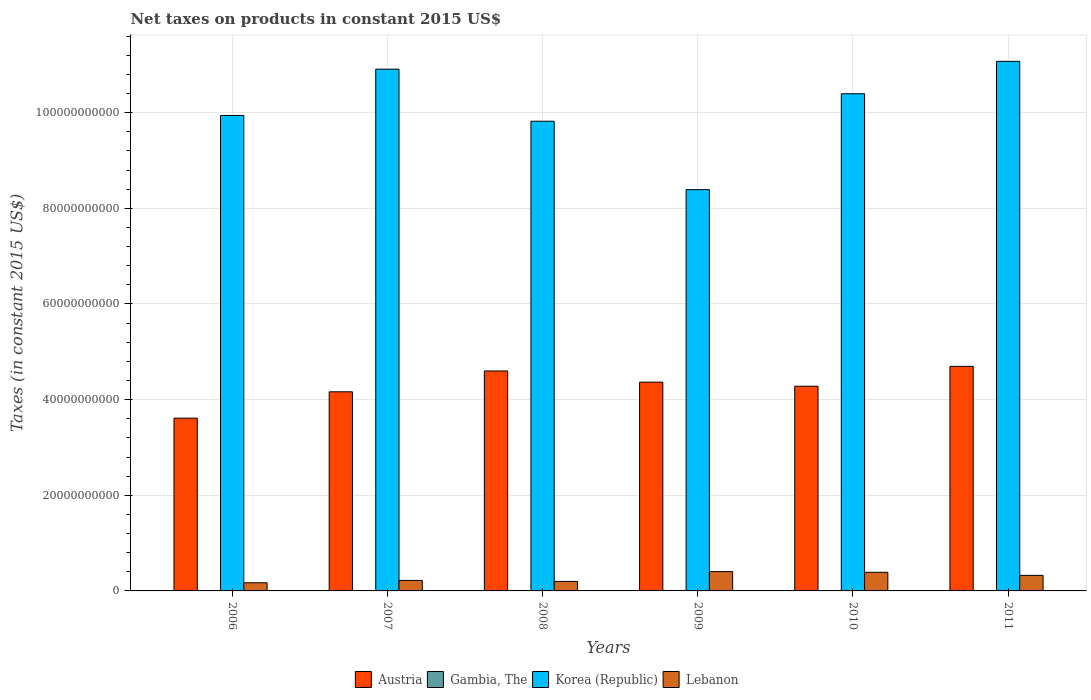How many different coloured bars are there?
Your answer should be compact. 4. How many groups of bars are there?
Give a very brief answer. 6. Are the number of bars on each tick of the X-axis equal?
Offer a very short reply. Yes. How many bars are there on the 5th tick from the right?
Give a very brief answer. 4. What is the label of the 3rd group of bars from the left?
Give a very brief answer. 2008. In how many cases, is the number of bars for a given year not equal to the number of legend labels?
Give a very brief answer. 0. What is the net taxes on products in Austria in 2008?
Provide a short and direct response. 4.60e+1. Across all years, what is the maximum net taxes on products in Austria?
Your answer should be compact. 4.70e+1. Across all years, what is the minimum net taxes on products in Korea (Republic)?
Provide a short and direct response. 8.39e+1. What is the total net taxes on products in Lebanon in the graph?
Provide a short and direct response. 1.71e+1. What is the difference between the net taxes on products in Austria in 2007 and that in 2010?
Your answer should be very brief. -1.16e+09. What is the difference between the net taxes on products in Gambia, The in 2008 and the net taxes on products in Lebanon in 2006?
Your response must be concise. -1.61e+09. What is the average net taxes on products in Gambia, The per year?
Keep it short and to the point. 8.42e+07. In the year 2010, what is the difference between the net taxes on products in Lebanon and net taxes on products in Korea (Republic)?
Provide a succinct answer. -1.00e+11. In how many years, is the net taxes on products in Lebanon greater than 104000000000 US$?
Give a very brief answer. 0. What is the ratio of the net taxes on products in Lebanon in 2007 to that in 2008?
Offer a terse response. 1.1. Is the difference between the net taxes on products in Lebanon in 2008 and 2009 greater than the difference between the net taxes on products in Korea (Republic) in 2008 and 2009?
Offer a terse response. No. What is the difference between the highest and the second highest net taxes on products in Lebanon?
Your response must be concise. 1.52e+08. What is the difference between the highest and the lowest net taxes on products in Austria?
Provide a short and direct response. 1.08e+1. In how many years, is the net taxes on products in Lebanon greater than the average net taxes on products in Lebanon taken over all years?
Ensure brevity in your answer.  3. Is it the case that in every year, the sum of the net taxes on products in Korea (Republic) and net taxes on products in Gambia, The is greater than the sum of net taxes on products in Lebanon and net taxes on products in Austria?
Make the answer very short. No. What does the 2nd bar from the right in 2011 represents?
Your response must be concise. Korea (Republic). How many bars are there?
Your answer should be very brief. 24. Are all the bars in the graph horizontal?
Keep it short and to the point. No. How many years are there in the graph?
Give a very brief answer. 6. What is the difference between two consecutive major ticks on the Y-axis?
Offer a terse response. 2.00e+1. Are the values on the major ticks of Y-axis written in scientific E-notation?
Ensure brevity in your answer.  No. How many legend labels are there?
Keep it short and to the point. 4. How are the legend labels stacked?
Give a very brief answer. Horizontal. What is the title of the graph?
Make the answer very short. Net taxes on products in constant 2015 US$. What is the label or title of the X-axis?
Provide a short and direct response. Years. What is the label or title of the Y-axis?
Offer a terse response. Taxes (in constant 2015 US$). What is the Taxes (in constant 2015 US$) of Austria in 2006?
Keep it short and to the point. 3.61e+1. What is the Taxes (in constant 2015 US$) in Gambia, The in 2006?
Provide a short and direct response. 6.61e+07. What is the Taxes (in constant 2015 US$) of Korea (Republic) in 2006?
Your answer should be very brief. 9.94e+1. What is the Taxes (in constant 2015 US$) of Lebanon in 2006?
Provide a short and direct response. 1.70e+09. What is the Taxes (in constant 2015 US$) in Austria in 2007?
Offer a terse response. 4.16e+1. What is the Taxes (in constant 2015 US$) of Gambia, The in 2007?
Provide a succinct answer. 8.66e+07. What is the Taxes (in constant 2015 US$) in Korea (Republic) in 2007?
Provide a succinct answer. 1.09e+11. What is the Taxes (in constant 2015 US$) of Lebanon in 2007?
Ensure brevity in your answer.  2.20e+09. What is the Taxes (in constant 2015 US$) of Austria in 2008?
Give a very brief answer. 4.60e+1. What is the Taxes (in constant 2015 US$) in Gambia, The in 2008?
Your response must be concise. 8.92e+07. What is the Taxes (in constant 2015 US$) in Korea (Republic) in 2008?
Provide a succinct answer. 9.82e+1. What is the Taxes (in constant 2015 US$) of Lebanon in 2008?
Your answer should be compact. 1.99e+09. What is the Taxes (in constant 2015 US$) of Austria in 2009?
Provide a succinct answer. 4.37e+1. What is the Taxes (in constant 2015 US$) in Gambia, The in 2009?
Give a very brief answer. 9.48e+07. What is the Taxes (in constant 2015 US$) in Korea (Republic) in 2009?
Keep it short and to the point. 8.39e+1. What is the Taxes (in constant 2015 US$) in Lebanon in 2009?
Your response must be concise. 4.04e+09. What is the Taxes (in constant 2015 US$) in Austria in 2010?
Give a very brief answer. 4.28e+1. What is the Taxes (in constant 2015 US$) in Gambia, The in 2010?
Offer a terse response. 8.39e+07. What is the Taxes (in constant 2015 US$) of Korea (Republic) in 2010?
Make the answer very short. 1.04e+11. What is the Taxes (in constant 2015 US$) of Lebanon in 2010?
Your answer should be compact. 3.89e+09. What is the Taxes (in constant 2015 US$) in Austria in 2011?
Your response must be concise. 4.70e+1. What is the Taxes (in constant 2015 US$) in Gambia, The in 2011?
Provide a succinct answer. 8.46e+07. What is the Taxes (in constant 2015 US$) in Korea (Republic) in 2011?
Provide a short and direct response. 1.11e+11. What is the Taxes (in constant 2015 US$) in Lebanon in 2011?
Offer a terse response. 3.25e+09. Across all years, what is the maximum Taxes (in constant 2015 US$) in Austria?
Offer a terse response. 4.70e+1. Across all years, what is the maximum Taxes (in constant 2015 US$) in Gambia, The?
Your answer should be very brief. 9.48e+07. Across all years, what is the maximum Taxes (in constant 2015 US$) in Korea (Republic)?
Provide a short and direct response. 1.11e+11. Across all years, what is the maximum Taxes (in constant 2015 US$) of Lebanon?
Keep it short and to the point. 4.04e+09. Across all years, what is the minimum Taxes (in constant 2015 US$) of Austria?
Make the answer very short. 3.61e+1. Across all years, what is the minimum Taxes (in constant 2015 US$) in Gambia, The?
Keep it short and to the point. 6.61e+07. Across all years, what is the minimum Taxes (in constant 2015 US$) of Korea (Republic)?
Your answer should be compact. 8.39e+1. Across all years, what is the minimum Taxes (in constant 2015 US$) in Lebanon?
Your answer should be very brief. 1.70e+09. What is the total Taxes (in constant 2015 US$) in Austria in the graph?
Make the answer very short. 2.57e+11. What is the total Taxes (in constant 2015 US$) in Gambia, The in the graph?
Make the answer very short. 5.05e+08. What is the total Taxes (in constant 2015 US$) of Korea (Republic) in the graph?
Your answer should be compact. 6.05e+11. What is the total Taxes (in constant 2015 US$) in Lebanon in the graph?
Ensure brevity in your answer.  1.71e+1. What is the difference between the Taxes (in constant 2015 US$) in Austria in 2006 and that in 2007?
Your answer should be very brief. -5.51e+09. What is the difference between the Taxes (in constant 2015 US$) of Gambia, The in 2006 and that in 2007?
Your answer should be very brief. -2.05e+07. What is the difference between the Taxes (in constant 2015 US$) of Korea (Republic) in 2006 and that in 2007?
Your answer should be very brief. -9.68e+09. What is the difference between the Taxes (in constant 2015 US$) of Lebanon in 2006 and that in 2007?
Your answer should be compact. -4.94e+08. What is the difference between the Taxes (in constant 2015 US$) of Austria in 2006 and that in 2008?
Your answer should be compact. -9.87e+09. What is the difference between the Taxes (in constant 2015 US$) in Gambia, The in 2006 and that in 2008?
Make the answer very short. -2.31e+07. What is the difference between the Taxes (in constant 2015 US$) in Korea (Republic) in 2006 and that in 2008?
Give a very brief answer. 1.21e+09. What is the difference between the Taxes (in constant 2015 US$) of Lebanon in 2006 and that in 2008?
Your answer should be very brief. -2.86e+08. What is the difference between the Taxes (in constant 2015 US$) of Austria in 2006 and that in 2009?
Provide a succinct answer. -7.53e+09. What is the difference between the Taxes (in constant 2015 US$) of Gambia, The in 2006 and that in 2009?
Ensure brevity in your answer.  -2.87e+07. What is the difference between the Taxes (in constant 2015 US$) of Korea (Republic) in 2006 and that in 2009?
Provide a short and direct response. 1.55e+1. What is the difference between the Taxes (in constant 2015 US$) in Lebanon in 2006 and that in 2009?
Offer a terse response. -2.34e+09. What is the difference between the Taxes (in constant 2015 US$) of Austria in 2006 and that in 2010?
Keep it short and to the point. -6.68e+09. What is the difference between the Taxes (in constant 2015 US$) in Gambia, The in 2006 and that in 2010?
Provide a short and direct response. -1.77e+07. What is the difference between the Taxes (in constant 2015 US$) of Korea (Republic) in 2006 and that in 2010?
Offer a very short reply. -4.54e+09. What is the difference between the Taxes (in constant 2015 US$) in Lebanon in 2006 and that in 2010?
Your answer should be very brief. -2.19e+09. What is the difference between the Taxes (in constant 2015 US$) in Austria in 2006 and that in 2011?
Ensure brevity in your answer.  -1.08e+1. What is the difference between the Taxes (in constant 2015 US$) of Gambia, The in 2006 and that in 2011?
Your answer should be compact. -1.85e+07. What is the difference between the Taxes (in constant 2015 US$) of Korea (Republic) in 2006 and that in 2011?
Offer a very short reply. -1.13e+1. What is the difference between the Taxes (in constant 2015 US$) of Lebanon in 2006 and that in 2011?
Offer a terse response. -1.55e+09. What is the difference between the Taxes (in constant 2015 US$) of Austria in 2007 and that in 2008?
Provide a short and direct response. -4.35e+09. What is the difference between the Taxes (in constant 2015 US$) in Gambia, The in 2007 and that in 2008?
Provide a short and direct response. -2.59e+06. What is the difference between the Taxes (in constant 2015 US$) of Korea (Republic) in 2007 and that in 2008?
Keep it short and to the point. 1.09e+1. What is the difference between the Taxes (in constant 2015 US$) of Lebanon in 2007 and that in 2008?
Keep it short and to the point. 2.08e+08. What is the difference between the Taxes (in constant 2015 US$) in Austria in 2007 and that in 2009?
Your response must be concise. -2.02e+09. What is the difference between the Taxes (in constant 2015 US$) of Gambia, The in 2007 and that in 2009?
Make the answer very short. -8.23e+06. What is the difference between the Taxes (in constant 2015 US$) of Korea (Republic) in 2007 and that in 2009?
Make the answer very short. 2.52e+1. What is the difference between the Taxes (in constant 2015 US$) in Lebanon in 2007 and that in 2009?
Your response must be concise. -1.85e+09. What is the difference between the Taxes (in constant 2015 US$) of Austria in 2007 and that in 2010?
Your answer should be very brief. -1.16e+09. What is the difference between the Taxes (in constant 2015 US$) of Gambia, The in 2007 and that in 2010?
Provide a short and direct response. 2.75e+06. What is the difference between the Taxes (in constant 2015 US$) in Korea (Republic) in 2007 and that in 2010?
Provide a succinct answer. 5.14e+09. What is the difference between the Taxes (in constant 2015 US$) of Lebanon in 2007 and that in 2010?
Ensure brevity in your answer.  -1.69e+09. What is the difference between the Taxes (in constant 2015 US$) in Austria in 2007 and that in 2011?
Provide a succinct answer. -5.32e+09. What is the difference between the Taxes (in constant 2015 US$) in Gambia, The in 2007 and that in 2011?
Offer a very short reply. 1.97e+06. What is the difference between the Taxes (in constant 2015 US$) of Korea (Republic) in 2007 and that in 2011?
Ensure brevity in your answer.  -1.63e+09. What is the difference between the Taxes (in constant 2015 US$) of Lebanon in 2007 and that in 2011?
Provide a succinct answer. -1.06e+09. What is the difference between the Taxes (in constant 2015 US$) in Austria in 2008 and that in 2009?
Give a very brief answer. 2.33e+09. What is the difference between the Taxes (in constant 2015 US$) in Gambia, The in 2008 and that in 2009?
Give a very brief answer. -5.63e+06. What is the difference between the Taxes (in constant 2015 US$) of Korea (Republic) in 2008 and that in 2009?
Offer a terse response. 1.43e+1. What is the difference between the Taxes (in constant 2015 US$) of Lebanon in 2008 and that in 2009?
Keep it short and to the point. -2.06e+09. What is the difference between the Taxes (in constant 2015 US$) in Austria in 2008 and that in 2010?
Provide a succinct answer. 3.19e+09. What is the difference between the Taxes (in constant 2015 US$) in Gambia, The in 2008 and that in 2010?
Your answer should be compact. 5.34e+06. What is the difference between the Taxes (in constant 2015 US$) of Korea (Republic) in 2008 and that in 2010?
Offer a very short reply. -5.75e+09. What is the difference between the Taxes (in constant 2015 US$) of Lebanon in 2008 and that in 2010?
Your response must be concise. -1.90e+09. What is the difference between the Taxes (in constant 2015 US$) of Austria in 2008 and that in 2011?
Your answer should be very brief. -9.63e+08. What is the difference between the Taxes (in constant 2015 US$) of Gambia, The in 2008 and that in 2011?
Offer a very short reply. 4.56e+06. What is the difference between the Taxes (in constant 2015 US$) of Korea (Republic) in 2008 and that in 2011?
Keep it short and to the point. -1.25e+1. What is the difference between the Taxes (in constant 2015 US$) in Lebanon in 2008 and that in 2011?
Offer a terse response. -1.27e+09. What is the difference between the Taxes (in constant 2015 US$) in Austria in 2009 and that in 2010?
Offer a terse response. 8.56e+08. What is the difference between the Taxes (in constant 2015 US$) of Gambia, The in 2009 and that in 2010?
Ensure brevity in your answer.  1.10e+07. What is the difference between the Taxes (in constant 2015 US$) in Korea (Republic) in 2009 and that in 2010?
Ensure brevity in your answer.  -2.01e+1. What is the difference between the Taxes (in constant 2015 US$) of Lebanon in 2009 and that in 2010?
Your response must be concise. 1.52e+08. What is the difference between the Taxes (in constant 2015 US$) in Austria in 2009 and that in 2011?
Offer a terse response. -3.29e+09. What is the difference between the Taxes (in constant 2015 US$) in Gambia, The in 2009 and that in 2011?
Keep it short and to the point. 1.02e+07. What is the difference between the Taxes (in constant 2015 US$) in Korea (Republic) in 2009 and that in 2011?
Keep it short and to the point. -2.68e+1. What is the difference between the Taxes (in constant 2015 US$) in Lebanon in 2009 and that in 2011?
Provide a short and direct response. 7.89e+08. What is the difference between the Taxes (in constant 2015 US$) in Austria in 2010 and that in 2011?
Give a very brief answer. -4.15e+09. What is the difference between the Taxes (in constant 2015 US$) of Gambia, The in 2010 and that in 2011?
Your answer should be compact. -7.83e+05. What is the difference between the Taxes (in constant 2015 US$) in Korea (Republic) in 2010 and that in 2011?
Keep it short and to the point. -6.77e+09. What is the difference between the Taxes (in constant 2015 US$) of Lebanon in 2010 and that in 2011?
Your response must be concise. 6.37e+08. What is the difference between the Taxes (in constant 2015 US$) in Austria in 2006 and the Taxes (in constant 2015 US$) in Gambia, The in 2007?
Your answer should be compact. 3.60e+1. What is the difference between the Taxes (in constant 2015 US$) in Austria in 2006 and the Taxes (in constant 2015 US$) in Korea (Republic) in 2007?
Provide a succinct answer. -7.30e+1. What is the difference between the Taxes (in constant 2015 US$) of Austria in 2006 and the Taxes (in constant 2015 US$) of Lebanon in 2007?
Give a very brief answer. 3.39e+1. What is the difference between the Taxes (in constant 2015 US$) in Gambia, The in 2006 and the Taxes (in constant 2015 US$) in Korea (Republic) in 2007?
Your response must be concise. -1.09e+11. What is the difference between the Taxes (in constant 2015 US$) of Gambia, The in 2006 and the Taxes (in constant 2015 US$) of Lebanon in 2007?
Offer a terse response. -2.13e+09. What is the difference between the Taxes (in constant 2015 US$) of Korea (Republic) in 2006 and the Taxes (in constant 2015 US$) of Lebanon in 2007?
Give a very brief answer. 9.72e+1. What is the difference between the Taxes (in constant 2015 US$) of Austria in 2006 and the Taxes (in constant 2015 US$) of Gambia, The in 2008?
Provide a short and direct response. 3.60e+1. What is the difference between the Taxes (in constant 2015 US$) in Austria in 2006 and the Taxes (in constant 2015 US$) in Korea (Republic) in 2008?
Offer a terse response. -6.21e+1. What is the difference between the Taxes (in constant 2015 US$) in Austria in 2006 and the Taxes (in constant 2015 US$) in Lebanon in 2008?
Your answer should be compact. 3.41e+1. What is the difference between the Taxes (in constant 2015 US$) of Gambia, The in 2006 and the Taxes (in constant 2015 US$) of Korea (Republic) in 2008?
Offer a terse response. -9.81e+1. What is the difference between the Taxes (in constant 2015 US$) of Gambia, The in 2006 and the Taxes (in constant 2015 US$) of Lebanon in 2008?
Keep it short and to the point. -1.92e+09. What is the difference between the Taxes (in constant 2015 US$) of Korea (Republic) in 2006 and the Taxes (in constant 2015 US$) of Lebanon in 2008?
Provide a succinct answer. 9.74e+1. What is the difference between the Taxes (in constant 2015 US$) in Austria in 2006 and the Taxes (in constant 2015 US$) in Gambia, The in 2009?
Your answer should be compact. 3.60e+1. What is the difference between the Taxes (in constant 2015 US$) of Austria in 2006 and the Taxes (in constant 2015 US$) of Korea (Republic) in 2009?
Your answer should be very brief. -4.78e+1. What is the difference between the Taxes (in constant 2015 US$) in Austria in 2006 and the Taxes (in constant 2015 US$) in Lebanon in 2009?
Offer a terse response. 3.21e+1. What is the difference between the Taxes (in constant 2015 US$) of Gambia, The in 2006 and the Taxes (in constant 2015 US$) of Korea (Republic) in 2009?
Offer a terse response. -8.38e+1. What is the difference between the Taxes (in constant 2015 US$) of Gambia, The in 2006 and the Taxes (in constant 2015 US$) of Lebanon in 2009?
Your response must be concise. -3.98e+09. What is the difference between the Taxes (in constant 2015 US$) of Korea (Republic) in 2006 and the Taxes (in constant 2015 US$) of Lebanon in 2009?
Offer a terse response. 9.54e+1. What is the difference between the Taxes (in constant 2015 US$) in Austria in 2006 and the Taxes (in constant 2015 US$) in Gambia, The in 2010?
Your answer should be very brief. 3.60e+1. What is the difference between the Taxes (in constant 2015 US$) of Austria in 2006 and the Taxes (in constant 2015 US$) of Korea (Republic) in 2010?
Ensure brevity in your answer.  -6.78e+1. What is the difference between the Taxes (in constant 2015 US$) of Austria in 2006 and the Taxes (in constant 2015 US$) of Lebanon in 2010?
Provide a short and direct response. 3.22e+1. What is the difference between the Taxes (in constant 2015 US$) in Gambia, The in 2006 and the Taxes (in constant 2015 US$) in Korea (Republic) in 2010?
Give a very brief answer. -1.04e+11. What is the difference between the Taxes (in constant 2015 US$) in Gambia, The in 2006 and the Taxes (in constant 2015 US$) in Lebanon in 2010?
Your answer should be compact. -3.83e+09. What is the difference between the Taxes (in constant 2015 US$) of Korea (Republic) in 2006 and the Taxes (in constant 2015 US$) of Lebanon in 2010?
Offer a very short reply. 9.55e+1. What is the difference between the Taxes (in constant 2015 US$) in Austria in 2006 and the Taxes (in constant 2015 US$) in Gambia, The in 2011?
Give a very brief answer. 3.60e+1. What is the difference between the Taxes (in constant 2015 US$) of Austria in 2006 and the Taxes (in constant 2015 US$) of Korea (Republic) in 2011?
Keep it short and to the point. -7.46e+1. What is the difference between the Taxes (in constant 2015 US$) of Austria in 2006 and the Taxes (in constant 2015 US$) of Lebanon in 2011?
Your response must be concise. 3.29e+1. What is the difference between the Taxes (in constant 2015 US$) of Gambia, The in 2006 and the Taxes (in constant 2015 US$) of Korea (Republic) in 2011?
Provide a succinct answer. -1.11e+11. What is the difference between the Taxes (in constant 2015 US$) of Gambia, The in 2006 and the Taxes (in constant 2015 US$) of Lebanon in 2011?
Offer a terse response. -3.19e+09. What is the difference between the Taxes (in constant 2015 US$) in Korea (Republic) in 2006 and the Taxes (in constant 2015 US$) in Lebanon in 2011?
Offer a terse response. 9.62e+1. What is the difference between the Taxes (in constant 2015 US$) of Austria in 2007 and the Taxes (in constant 2015 US$) of Gambia, The in 2008?
Give a very brief answer. 4.15e+1. What is the difference between the Taxes (in constant 2015 US$) in Austria in 2007 and the Taxes (in constant 2015 US$) in Korea (Republic) in 2008?
Provide a short and direct response. -5.66e+1. What is the difference between the Taxes (in constant 2015 US$) in Austria in 2007 and the Taxes (in constant 2015 US$) in Lebanon in 2008?
Your answer should be compact. 3.96e+1. What is the difference between the Taxes (in constant 2015 US$) in Gambia, The in 2007 and the Taxes (in constant 2015 US$) in Korea (Republic) in 2008?
Offer a very short reply. -9.81e+1. What is the difference between the Taxes (in constant 2015 US$) of Gambia, The in 2007 and the Taxes (in constant 2015 US$) of Lebanon in 2008?
Provide a short and direct response. -1.90e+09. What is the difference between the Taxes (in constant 2015 US$) in Korea (Republic) in 2007 and the Taxes (in constant 2015 US$) in Lebanon in 2008?
Provide a short and direct response. 1.07e+11. What is the difference between the Taxes (in constant 2015 US$) in Austria in 2007 and the Taxes (in constant 2015 US$) in Gambia, The in 2009?
Your answer should be compact. 4.15e+1. What is the difference between the Taxes (in constant 2015 US$) of Austria in 2007 and the Taxes (in constant 2015 US$) of Korea (Republic) in 2009?
Give a very brief answer. -4.23e+1. What is the difference between the Taxes (in constant 2015 US$) of Austria in 2007 and the Taxes (in constant 2015 US$) of Lebanon in 2009?
Provide a short and direct response. 3.76e+1. What is the difference between the Taxes (in constant 2015 US$) of Gambia, The in 2007 and the Taxes (in constant 2015 US$) of Korea (Republic) in 2009?
Offer a very short reply. -8.38e+1. What is the difference between the Taxes (in constant 2015 US$) in Gambia, The in 2007 and the Taxes (in constant 2015 US$) in Lebanon in 2009?
Provide a short and direct response. -3.96e+09. What is the difference between the Taxes (in constant 2015 US$) of Korea (Republic) in 2007 and the Taxes (in constant 2015 US$) of Lebanon in 2009?
Offer a very short reply. 1.05e+11. What is the difference between the Taxes (in constant 2015 US$) in Austria in 2007 and the Taxes (in constant 2015 US$) in Gambia, The in 2010?
Provide a short and direct response. 4.16e+1. What is the difference between the Taxes (in constant 2015 US$) of Austria in 2007 and the Taxes (in constant 2015 US$) of Korea (Republic) in 2010?
Make the answer very short. -6.23e+1. What is the difference between the Taxes (in constant 2015 US$) in Austria in 2007 and the Taxes (in constant 2015 US$) in Lebanon in 2010?
Give a very brief answer. 3.77e+1. What is the difference between the Taxes (in constant 2015 US$) in Gambia, The in 2007 and the Taxes (in constant 2015 US$) in Korea (Republic) in 2010?
Give a very brief answer. -1.04e+11. What is the difference between the Taxes (in constant 2015 US$) of Gambia, The in 2007 and the Taxes (in constant 2015 US$) of Lebanon in 2010?
Your answer should be compact. -3.80e+09. What is the difference between the Taxes (in constant 2015 US$) in Korea (Republic) in 2007 and the Taxes (in constant 2015 US$) in Lebanon in 2010?
Your answer should be very brief. 1.05e+11. What is the difference between the Taxes (in constant 2015 US$) in Austria in 2007 and the Taxes (in constant 2015 US$) in Gambia, The in 2011?
Provide a succinct answer. 4.16e+1. What is the difference between the Taxes (in constant 2015 US$) of Austria in 2007 and the Taxes (in constant 2015 US$) of Korea (Republic) in 2011?
Offer a very short reply. -6.91e+1. What is the difference between the Taxes (in constant 2015 US$) in Austria in 2007 and the Taxes (in constant 2015 US$) in Lebanon in 2011?
Ensure brevity in your answer.  3.84e+1. What is the difference between the Taxes (in constant 2015 US$) of Gambia, The in 2007 and the Taxes (in constant 2015 US$) of Korea (Republic) in 2011?
Provide a succinct answer. -1.11e+11. What is the difference between the Taxes (in constant 2015 US$) in Gambia, The in 2007 and the Taxes (in constant 2015 US$) in Lebanon in 2011?
Your answer should be very brief. -3.17e+09. What is the difference between the Taxes (in constant 2015 US$) in Korea (Republic) in 2007 and the Taxes (in constant 2015 US$) in Lebanon in 2011?
Make the answer very short. 1.06e+11. What is the difference between the Taxes (in constant 2015 US$) of Austria in 2008 and the Taxes (in constant 2015 US$) of Gambia, The in 2009?
Give a very brief answer. 4.59e+1. What is the difference between the Taxes (in constant 2015 US$) in Austria in 2008 and the Taxes (in constant 2015 US$) in Korea (Republic) in 2009?
Offer a terse response. -3.79e+1. What is the difference between the Taxes (in constant 2015 US$) of Austria in 2008 and the Taxes (in constant 2015 US$) of Lebanon in 2009?
Your answer should be very brief. 4.19e+1. What is the difference between the Taxes (in constant 2015 US$) in Gambia, The in 2008 and the Taxes (in constant 2015 US$) in Korea (Republic) in 2009?
Offer a very short reply. -8.38e+1. What is the difference between the Taxes (in constant 2015 US$) of Gambia, The in 2008 and the Taxes (in constant 2015 US$) of Lebanon in 2009?
Make the answer very short. -3.95e+09. What is the difference between the Taxes (in constant 2015 US$) in Korea (Republic) in 2008 and the Taxes (in constant 2015 US$) in Lebanon in 2009?
Make the answer very short. 9.42e+1. What is the difference between the Taxes (in constant 2015 US$) of Austria in 2008 and the Taxes (in constant 2015 US$) of Gambia, The in 2010?
Ensure brevity in your answer.  4.59e+1. What is the difference between the Taxes (in constant 2015 US$) in Austria in 2008 and the Taxes (in constant 2015 US$) in Korea (Republic) in 2010?
Make the answer very short. -5.80e+1. What is the difference between the Taxes (in constant 2015 US$) in Austria in 2008 and the Taxes (in constant 2015 US$) in Lebanon in 2010?
Your response must be concise. 4.21e+1. What is the difference between the Taxes (in constant 2015 US$) of Gambia, The in 2008 and the Taxes (in constant 2015 US$) of Korea (Republic) in 2010?
Your answer should be very brief. -1.04e+11. What is the difference between the Taxes (in constant 2015 US$) in Gambia, The in 2008 and the Taxes (in constant 2015 US$) in Lebanon in 2010?
Give a very brief answer. -3.80e+09. What is the difference between the Taxes (in constant 2015 US$) in Korea (Republic) in 2008 and the Taxes (in constant 2015 US$) in Lebanon in 2010?
Your answer should be compact. 9.43e+1. What is the difference between the Taxes (in constant 2015 US$) of Austria in 2008 and the Taxes (in constant 2015 US$) of Gambia, The in 2011?
Keep it short and to the point. 4.59e+1. What is the difference between the Taxes (in constant 2015 US$) in Austria in 2008 and the Taxes (in constant 2015 US$) in Korea (Republic) in 2011?
Your answer should be very brief. -6.47e+1. What is the difference between the Taxes (in constant 2015 US$) of Austria in 2008 and the Taxes (in constant 2015 US$) of Lebanon in 2011?
Give a very brief answer. 4.27e+1. What is the difference between the Taxes (in constant 2015 US$) in Gambia, The in 2008 and the Taxes (in constant 2015 US$) in Korea (Republic) in 2011?
Provide a short and direct response. -1.11e+11. What is the difference between the Taxes (in constant 2015 US$) of Gambia, The in 2008 and the Taxes (in constant 2015 US$) of Lebanon in 2011?
Your response must be concise. -3.16e+09. What is the difference between the Taxes (in constant 2015 US$) in Korea (Republic) in 2008 and the Taxes (in constant 2015 US$) in Lebanon in 2011?
Your response must be concise. 9.50e+1. What is the difference between the Taxes (in constant 2015 US$) in Austria in 2009 and the Taxes (in constant 2015 US$) in Gambia, The in 2010?
Offer a terse response. 4.36e+1. What is the difference between the Taxes (in constant 2015 US$) of Austria in 2009 and the Taxes (in constant 2015 US$) of Korea (Republic) in 2010?
Ensure brevity in your answer.  -6.03e+1. What is the difference between the Taxes (in constant 2015 US$) of Austria in 2009 and the Taxes (in constant 2015 US$) of Lebanon in 2010?
Your response must be concise. 3.98e+1. What is the difference between the Taxes (in constant 2015 US$) of Gambia, The in 2009 and the Taxes (in constant 2015 US$) of Korea (Republic) in 2010?
Make the answer very short. -1.04e+11. What is the difference between the Taxes (in constant 2015 US$) of Gambia, The in 2009 and the Taxes (in constant 2015 US$) of Lebanon in 2010?
Give a very brief answer. -3.80e+09. What is the difference between the Taxes (in constant 2015 US$) of Korea (Republic) in 2009 and the Taxes (in constant 2015 US$) of Lebanon in 2010?
Your answer should be compact. 8.00e+1. What is the difference between the Taxes (in constant 2015 US$) in Austria in 2009 and the Taxes (in constant 2015 US$) in Gambia, The in 2011?
Offer a very short reply. 4.36e+1. What is the difference between the Taxes (in constant 2015 US$) in Austria in 2009 and the Taxes (in constant 2015 US$) in Korea (Republic) in 2011?
Provide a succinct answer. -6.71e+1. What is the difference between the Taxes (in constant 2015 US$) in Austria in 2009 and the Taxes (in constant 2015 US$) in Lebanon in 2011?
Keep it short and to the point. 4.04e+1. What is the difference between the Taxes (in constant 2015 US$) in Gambia, The in 2009 and the Taxes (in constant 2015 US$) in Korea (Republic) in 2011?
Your answer should be very brief. -1.11e+11. What is the difference between the Taxes (in constant 2015 US$) of Gambia, The in 2009 and the Taxes (in constant 2015 US$) of Lebanon in 2011?
Your answer should be very brief. -3.16e+09. What is the difference between the Taxes (in constant 2015 US$) of Korea (Republic) in 2009 and the Taxes (in constant 2015 US$) of Lebanon in 2011?
Your response must be concise. 8.07e+1. What is the difference between the Taxes (in constant 2015 US$) in Austria in 2010 and the Taxes (in constant 2015 US$) in Gambia, The in 2011?
Keep it short and to the point. 4.27e+1. What is the difference between the Taxes (in constant 2015 US$) in Austria in 2010 and the Taxes (in constant 2015 US$) in Korea (Republic) in 2011?
Ensure brevity in your answer.  -6.79e+1. What is the difference between the Taxes (in constant 2015 US$) in Austria in 2010 and the Taxes (in constant 2015 US$) in Lebanon in 2011?
Keep it short and to the point. 3.95e+1. What is the difference between the Taxes (in constant 2015 US$) of Gambia, The in 2010 and the Taxes (in constant 2015 US$) of Korea (Republic) in 2011?
Your response must be concise. -1.11e+11. What is the difference between the Taxes (in constant 2015 US$) in Gambia, The in 2010 and the Taxes (in constant 2015 US$) in Lebanon in 2011?
Your answer should be very brief. -3.17e+09. What is the difference between the Taxes (in constant 2015 US$) of Korea (Republic) in 2010 and the Taxes (in constant 2015 US$) of Lebanon in 2011?
Offer a very short reply. 1.01e+11. What is the average Taxes (in constant 2015 US$) of Austria per year?
Make the answer very short. 4.29e+1. What is the average Taxes (in constant 2015 US$) in Gambia, The per year?
Your answer should be compact. 8.42e+07. What is the average Taxes (in constant 2015 US$) of Korea (Republic) per year?
Offer a very short reply. 1.01e+11. What is the average Taxes (in constant 2015 US$) of Lebanon per year?
Make the answer very short. 2.85e+09. In the year 2006, what is the difference between the Taxes (in constant 2015 US$) in Austria and Taxes (in constant 2015 US$) in Gambia, The?
Keep it short and to the point. 3.61e+1. In the year 2006, what is the difference between the Taxes (in constant 2015 US$) in Austria and Taxes (in constant 2015 US$) in Korea (Republic)?
Offer a terse response. -6.33e+1. In the year 2006, what is the difference between the Taxes (in constant 2015 US$) in Austria and Taxes (in constant 2015 US$) in Lebanon?
Ensure brevity in your answer.  3.44e+1. In the year 2006, what is the difference between the Taxes (in constant 2015 US$) of Gambia, The and Taxes (in constant 2015 US$) of Korea (Republic)?
Make the answer very short. -9.94e+1. In the year 2006, what is the difference between the Taxes (in constant 2015 US$) of Gambia, The and Taxes (in constant 2015 US$) of Lebanon?
Make the answer very short. -1.64e+09. In the year 2006, what is the difference between the Taxes (in constant 2015 US$) in Korea (Republic) and Taxes (in constant 2015 US$) in Lebanon?
Give a very brief answer. 9.77e+1. In the year 2007, what is the difference between the Taxes (in constant 2015 US$) in Austria and Taxes (in constant 2015 US$) in Gambia, The?
Give a very brief answer. 4.16e+1. In the year 2007, what is the difference between the Taxes (in constant 2015 US$) of Austria and Taxes (in constant 2015 US$) of Korea (Republic)?
Offer a terse response. -6.75e+1. In the year 2007, what is the difference between the Taxes (in constant 2015 US$) in Austria and Taxes (in constant 2015 US$) in Lebanon?
Keep it short and to the point. 3.94e+1. In the year 2007, what is the difference between the Taxes (in constant 2015 US$) of Gambia, The and Taxes (in constant 2015 US$) of Korea (Republic)?
Keep it short and to the point. -1.09e+11. In the year 2007, what is the difference between the Taxes (in constant 2015 US$) in Gambia, The and Taxes (in constant 2015 US$) in Lebanon?
Ensure brevity in your answer.  -2.11e+09. In the year 2007, what is the difference between the Taxes (in constant 2015 US$) of Korea (Republic) and Taxes (in constant 2015 US$) of Lebanon?
Offer a very short reply. 1.07e+11. In the year 2008, what is the difference between the Taxes (in constant 2015 US$) of Austria and Taxes (in constant 2015 US$) of Gambia, The?
Provide a short and direct response. 4.59e+1. In the year 2008, what is the difference between the Taxes (in constant 2015 US$) of Austria and Taxes (in constant 2015 US$) of Korea (Republic)?
Your response must be concise. -5.22e+1. In the year 2008, what is the difference between the Taxes (in constant 2015 US$) in Austria and Taxes (in constant 2015 US$) in Lebanon?
Keep it short and to the point. 4.40e+1. In the year 2008, what is the difference between the Taxes (in constant 2015 US$) of Gambia, The and Taxes (in constant 2015 US$) of Korea (Republic)?
Keep it short and to the point. -9.81e+1. In the year 2008, what is the difference between the Taxes (in constant 2015 US$) of Gambia, The and Taxes (in constant 2015 US$) of Lebanon?
Offer a terse response. -1.90e+09. In the year 2008, what is the difference between the Taxes (in constant 2015 US$) of Korea (Republic) and Taxes (in constant 2015 US$) of Lebanon?
Your answer should be compact. 9.62e+1. In the year 2009, what is the difference between the Taxes (in constant 2015 US$) in Austria and Taxes (in constant 2015 US$) in Gambia, The?
Make the answer very short. 4.36e+1. In the year 2009, what is the difference between the Taxes (in constant 2015 US$) of Austria and Taxes (in constant 2015 US$) of Korea (Republic)?
Make the answer very short. -4.02e+1. In the year 2009, what is the difference between the Taxes (in constant 2015 US$) of Austria and Taxes (in constant 2015 US$) of Lebanon?
Keep it short and to the point. 3.96e+1. In the year 2009, what is the difference between the Taxes (in constant 2015 US$) in Gambia, The and Taxes (in constant 2015 US$) in Korea (Republic)?
Provide a succinct answer. -8.38e+1. In the year 2009, what is the difference between the Taxes (in constant 2015 US$) in Gambia, The and Taxes (in constant 2015 US$) in Lebanon?
Offer a very short reply. -3.95e+09. In the year 2009, what is the difference between the Taxes (in constant 2015 US$) of Korea (Republic) and Taxes (in constant 2015 US$) of Lebanon?
Make the answer very short. 7.99e+1. In the year 2010, what is the difference between the Taxes (in constant 2015 US$) in Austria and Taxes (in constant 2015 US$) in Gambia, The?
Offer a terse response. 4.27e+1. In the year 2010, what is the difference between the Taxes (in constant 2015 US$) in Austria and Taxes (in constant 2015 US$) in Korea (Republic)?
Provide a short and direct response. -6.12e+1. In the year 2010, what is the difference between the Taxes (in constant 2015 US$) in Austria and Taxes (in constant 2015 US$) in Lebanon?
Ensure brevity in your answer.  3.89e+1. In the year 2010, what is the difference between the Taxes (in constant 2015 US$) in Gambia, The and Taxes (in constant 2015 US$) in Korea (Republic)?
Your answer should be compact. -1.04e+11. In the year 2010, what is the difference between the Taxes (in constant 2015 US$) of Gambia, The and Taxes (in constant 2015 US$) of Lebanon?
Keep it short and to the point. -3.81e+09. In the year 2010, what is the difference between the Taxes (in constant 2015 US$) in Korea (Republic) and Taxes (in constant 2015 US$) in Lebanon?
Provide a short and direct response. 1.00e+11. In the year 2011, what is the difference between the Taxes (in constant 2015 US$) of Austria and Taxes (in constant 2015 US$) of Gambia, The?
Make the answer very short. 4.69e+1. In the year 2011, what is the difference between the Taxes (in constant 2015 US$) of Austria and Taxes (in constant 2015 US$) of Korea (Republic)?
Give a very brief answer. -6.38e+1. In the year 2011, what is the difference between the Taxes (in constant 2015 US$) of Austria and Taxes (in constant 2015 US$) of Lebanon?
Ensure brevity in your answer.  4.37e+1. In the year 2011, what is the difference between the Taxes (in constant 2015 US$) in Gambia, The and Taxes (in constant 2015 US$) in Korea (Republic)?
Ensure brevity in your answer.  -1.11e+11. In the year 2011, what is the difference between the Taxes (in constant 2015 US$) in Gambia, The and Taxes (in constant 2015 US$) in Lebanon?
Make the answer very short. -3.17e+09. In the year 2011, what is the difference between the Taxes (in constant 2015 US$) in Korea (Republic) and Taxes (in constant 2015 US$) in Lebanon?
Your answer should be very brief. 1.07e+11. What is the ratio of the Taxes (in constant 2015 US$) in Austria in 2006 to that in 2007?
Ensure brevity in your answer.  0.87. What is the ratio of the Taxes (in constant 2015 US$) of Gambia, The in 2006 to that in 2007?
Your answer should be very brief. 0.76. What is the ratio of the Taxes (in constant 2015 US$) of Korea (Republic) in 2006 to that in 2007?
Offer a very short reply. 0.91. What is the ratio of the Taxes (in constant 2015 US$) of Lebanon in 2006 to that in 2007?
Keep it short and to the point. 0.78. What is the ratio of the Taxes (in constant 2015 US$) in Austria in 2006 to that in 2008?
Offer a very short reply. 0.79. What is the ratio of the Taxes (in constant 2015 US$) of Gambia, The in 2006 to that in 2008?
Your answer should be compact. 0.74. What is the ratio of the Taxes (in constant 2015 US$) in Korea (Republic) in 2006 to that in 2008?
Your response must be concise. 1.01. What is the ratio of the Taxes (in constant 2015 US$) of Lebanon in 2006 to that in 2008?
Offer a terse response. 0.86. What is the ratio of the Taxes (in constant 2015 US$) in Austria in 2006 to that in 2009?
Your answer should be very brief. 0.83. What is the ratio of the Taxes (in constant 2015 US$) in Gambia, The in 2006 to that in 2009?
Offer a terse response. 0.7. What is the ratio of the Taxes (in constant 2015 US$) of Korea (Republic) in 2006 to that in 2009?
Your response must be concise. 1.18. What is the ratio of the Taxes (in constant 2015 US$) of Lebanon in 2006 to that in 2009?
Give a very brief answer. 0.42. What is the ratio of the Taxes (in constant 2015 US$) in Austria in 2006 to that in 2010?
Offer a terse response. 0.84. What is the ratio of the Taxes (in constant 2015 US$) of Gambia, The in 2006 to that in 2010?
Ensure brevity in your answer.  0.79. What is the ratio of the Taxes (in constant 2015 US$) in Korea (Republic) in 2006 to that in 2010?
Keep it short and to the point. 0.96. What is the ratio of the Taxes (in constant 2015 US$) in Lebanon in 2006 to that in 2010?
Make the answer very short. 0.44. What is the ratio of the Taxes (in constant 2015 US$) of Austria in 2006 to that in 2011?
Provide a short and direct response. 0.77. What is the ratio of the Taxes (in constant 2015 US$) in Gambia, The in 2006 to that in 2011?
Your answer should be compact. 0.78. What is the ratio of the Taxes (in constant 2015 US$) of Korea (Republic) in 2006 to that in 2011?
Make the answer very short. 0.9. What is the ratio of the Taxes (in constant 2015 US$) in Lebanon in 2006 to that in 2011?
Provide a short and direct response. 0.52. What is the ratio of the Taxes (in constant 2015 US$) in Austria in 2007 to that in 2008?
Ensure brevity in your answer.  0.91. What is the ratio of the Taxes (in constant 2015 US$) in Gambia, The in 2007 to that in 2008?
Give a very brief answer. 0.97. What is the ratio of the Taxes (in constant 2015 US$) in Korea (Republic) in 2007 to that in 2008?
Offer a very short reply. 1.11. What is the ratio of the Taxes (in constant 2015 US$) in Lebanon in 2007 to that in 2008?
Make the answer very short. 1.1. What is the ratio of the Taxes (in constant 2015 US$) in Austria in 2007 to that in 2009?
Give a very brief answer. 0.95. What is the ratio of the Taxes (in constant 2015 US$) in Gambia, The in 2007 to that in 2009?
Provide a succinct answer. 0.91. What is the ratio of the Taxes (in constant 2015 US$) in Korea (Republic) in 2007 to that in 2009?
Make the answer very short. 1.3. What is the ratio of the Taxes (in constant 2015 US$) of Lebanon in 2007 to that in 2009?
Your answer should be very brief. 0.54. What is the ratio of the Taxes (in constant 2015 US$) in Austria in 2007 to that in 2010?
Ensure brevity in your answer.  0.97. What is the ratio of the Taxes (in constant 2015 US$) in Gambia, The in 2007 to that in 2010?
Ensure brevity in your answer.  1.03. What is the ratio of the Taxes (in constant 2015 US$) of Korea (Republic) in 2007 to that in 2010?
Ensure brevity in your answer.  1.05. What is the ratio of the Taxes (in constant 2015 US$) of Lebanon in 2007 to that in 2010?
Your response must be concise. 0.56. What is the ratio of the Taxes (in constant 2015 US$) of Austria in 2007 to that in 2011?
Offer a very short reply. 0.89. What is the ratio of the Taxes (in constant 2015 US$) in Gambia, The in 2007 to that in 2011?
Your response must be concise. 1.02. What is the ratio of the Taxes (in constant 2015 US$) in Korea (Republic) in 2007 to that in 2011?
Your answer should be very brief. 0.99. What is the ratio of the Taxes (in constant 2015 US$) of Lebanon in 2007 to that in 2011?
Your response must be concise. 0.68. What is the ratio of the Taxes (in constant 2015 US$) of Austria in 2008 to that in 2009?
Your answer should be very brief. 1.05. What is the ratio of the Taxes (in constant 2015 US$) in Gambia, The in 2008 to that in 2009?
Your answer should be very brief. 0.94. What is the ratio of the Taxes (in constant 2015 US$) of Korea (Republic) in 2008 to that in 2009?
Offer a terse response. 1.17. What is the ratio of the Taxes (in constant 2015 US$) of Lebanon in 2008 to that in 2009?
Your answer should be very brief. 0.49. What is the ratio of the Taxes (in constant 2015 US$) of Austria in 2008 to that in 2010?
Provide a short and direct response. 1.07. What is the ratio of the Taxes (in constant 2015 US$) of Gambia, The in 2008 to that in 2010?
Give a very brief answer. 1.06. What is the ratio of the Taxes (in constant 2015 US$) of Korea (Republic) in 2008 to that in 2010?
Offer a terse response. 0.94. What is the ratio of the Taxes (in constant 2015 US$) in Lebanon in 2008 to that in 2010?
Ensure brevity in your answer.  0.51. What is the ratio of the Taxes (in constant 2015 US$) of Austria in 2008 to that in 2011?
Provide a succinct answer. 0.98. What is the ratio of the Taxes (in constant 2015 US$) in Gambia, The in 2008 to that in 2011?
Provide a short and direct response. 1.05. What is the ratio of the Taxes (in constant 2015 US$) of Korea (Republic) in 2008 to that in 2011?
Ensure brevity in your answer.  0.89. What is the ratio of the Taxes (in constant 2015 US$) of Lebanon in 2008 to that in 2011?
Offer a terse response. 0.61. What is the ratio of the Taxes (in constant 2015 US$) of Gambia, The in 2009 to that in 2010?
Give a very brief answer. 1.13. What is the ratio of the Taxes (in constant 2015 US$) in Korea (Republic) in 2009 to that in 2010?
Keep it short and to the point. 0.81. What is the ratio of the Taxes (in constant 2015 US$) in Lebanon in 2009 to that in 2010?
Your answer should be very brief. 1.04. What is the ratio of the Taxes (in constant 2015 US$) of Austria in 2009 to that in 2011?
Give a very brief answer. 0.93. What is the ratio of the Taxes (in constant 2015 US$) of Gambia, The in 2009 to that in 2011?
Offer a very short reply. 1.12. What is the ratio of the Taxes (in constant 2015 US$) in Korea (Republic) in 2009 to that in 2011?
Offer a very short reply. 0.76. What is the ratio of the Taxes (in constant 2015 US$) in Lebanon in 2009 to that in 2011?
Give a very brief answer. 1.24. What is the ratio of the Taxes (in constant 2015 US$) in Austria in 2010 to that in 2011?
Offer a very short reply. 0.91. What is the ratio of the Taxes (in constant 2015 US$) in Korea (Republic) in 2010 to that in 2011?
Provide a succinct answer. 0.94. What is the ratio of the Taxes (in constant 2015 US$) of Lebanon in 2010 to that in 2011?
Your response must be concise. 1.2. What is the difference between the highest and the second highest Taxes (in constant 2015 US$) of Austria?
Provide a short and direct response. 9.63e+08. What is the difference between the highest and the second highest Taxes (in constant 2015 US$) of Gambia, The?
Offer a very short reply. 5.63e+06. What is the difference between the highest and the second highest Taxes (in constant 2015 US$) in Korea (Republic)?
Your answer should be very brief. 1.63e+09. What is the difference between the highest and the second highest Taxes (in constant 2015 US$) in Lebanon?
Make the answer very short. 1.52e+08. What is the difference between the highest and the lowest Taxes (in constant 2015 US$) of Austria?
Provide a succinct answer. 1.08e+1. What is the difference between the highest and the lowest Taxes (in constant 2015 US$) of Gambia, The?
Ensure brevity in your answer.  2.87e+07. What is the difference between the highest and the lowest Taxes (in constant 2015 US$) of Korea (Republic)?
Make the answer very short. 2.68e+1. What is the difference between the highest and the lowest Taxes (in constant 2015 US$) of Lebanon?
Ensure brevity in your answer.  2.34e+09. 